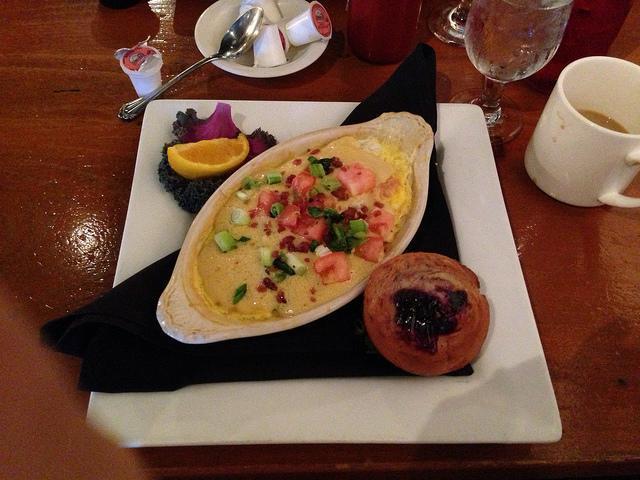How many bowls are there?
Give a very brief answer. 2. 